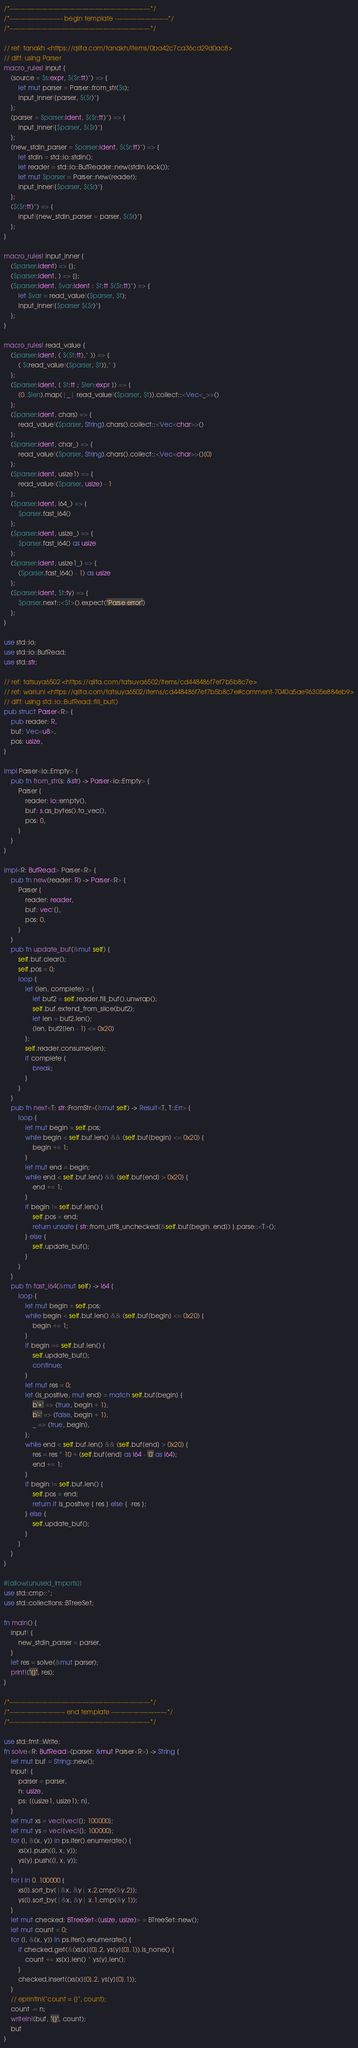Convert code to text. <code><loc_0><loc_0><loc_500><loc_500><_Rust_>/*------------------------------------------------------------------*/
/*------------------------- begin template -------------------------*/
/*------------------------------------------------------------------*/

// ref: tanakh <https://qiita.com/tanakh/items/0ba42c7ca36cd29d0ac8>
// diff: using Parser
macro_rules! input {
    (source = $s:expr, $($r:tt)*) => {
        let mut parser = Parser::from_str($s);
        input_inner!{parser, $($r)*}
    };
    (parser = $parser:ident, $($r:tt)*) => {
        input_inner!{$parser, $($r)*}
    };
    (new_stdin_parser = $parser:ident, $($r:tt)*) => {
        let stdin = std::io::stdin();
        let reader = std::io::BufReader::new(stdin.lock());
        let mut $parser = Parser::new(reader);
        input_inner!{$parser, $($r)*}
    };
    ($($r:tt)*) => {
        input!{new_stdin_parser = parser, $($r)*}
    };
}

macro_rules! input_inner {
    ($parser:ident) => {};
    ($parser:ident, ) => {};
    ($parser:ident, $var:ident : $t:tt $($r:tt)*) => {
        let $var = read_value!($parser, $t);
        input_inner!{$parser $($r)*}
    };
}

macro_rules! read_value {
    ($parser:ident, ( $($t:tt),* )) => {
        ( $(read_value!($parser, $t)),* )
    };
    ($parser:ident, [ $t:tt ; $len:expr ]) => {
        (0..$len).map(|_| read_value!($parser, $t)).collect::<Vec<_>>()
    };
    ($parser:ident, chars) => {
        read_value!($parser, String).chars().collect::<Vec<char>>()
    };
    ($parser:ident, char_) => {
        read_value!($parser, String).chars().collect::<Vec<char>>()[0]
    };
    ($parser:ident, usize1) => {
        read_value!($parser, usize) - 1
    };
    ($parser:ident, i64_) => {
        $parser.fast_i64()
    };
    ($parser:ident, usize_) => {
        $parser.fast_i64() as usize
    };
    ($parser:ident, usize1_) => {
        ($parser.fast_i64() - 1) as usize
    };
    ($parser:ident, $t:ty) => {
        $parser.next::<$t>().expect("Parse error")
    };
}

use std::io;
use std::io::BufRead;
use std::str;

// ref: tatsuya6502 <https://qiita.com/tatsuya6502/items/cd448486f7ef7b5b8c7e>
// ref: wariuni <https://qiita.com/tatsuya6502/items/cd448486f7ef7b5b8c7e#comment-7040a5ae96305e884eb9>
// diff: using std::io::BufRead::fill_buf()
pub struct Parser<R> {
    pub reader: R,
    buf: Vec<u8>,
    pos: usize,
}

impl Parser<io::Empty> {
    pub fn from_str(s: &str) -> Parser<io::Empty> {
        Parser {
            reader: io::empty(),
            buf: s.as_bytes().to_vec(),
            pos: 0,
        }
    }
}

impl<R: BufRead> Parser<R> {
    pub fn new(reader: R) -> Parser<R> {
        Parser {
            reader: reader,
            buf: vec![],
            pos: 0,
        }
    }
    pub fn update_buf(&mut self) {
        self.buf.clear();
        self.pos = 0;
        loop {
            let (len, complete) = {
                let buf2 = self.reader.fill_buf().unwrap();
                self.buf.extend_from_slice(buf2);
                let len = buf2.len();
                (len, buf2[len - 1] <= 0x20)
            };
            self.reader.consume(len);
            if complete {
                break;
            }
        }
    }
    pub fn next<T: str::FromStr>(&mut self) -> Result<T, T::Err> {
        loop {
            let mut begin = self.pos;
            while begin < self.buf.len() && (self.buf[begin] <= 0x20) {
                begin += 1;
            }
            let mut end = begin;
            while end < self.buf.len() && (self.buf[end] > 0x20) {
                end += 1;
            }
            if begin != self.buf.len() {
                self.pos = end;
                return unsafe { str::from_utf8_unchecked(&self.buf[begin..end]) }.parse::<T>();
            } else {
                self.update_buf();
            }
        }
    }
    pub fn fast_i64(&mut self) -> i64 {
        loop {
            let mut begin = self.pos;
            while begin < self.buf.len() && (self.buf[begin] <= 0x20) {
                begin += 1;
            }
            if begin == self.buf.len() {
                self.update_buf();
                continue;
            }
            let mut res = 0;
            let (is_positive, mut end) = match self.buf[begin] {
                b'+' => (true, begin + 1),
                b'-' => (false, begin + 1),
                _ => (true, begin),
            };
            while end < self.buf.len() && (self.buf[end] > 0x20) {
                res = res * 10 + (self.buf[end] as i64 - '0' as i64);
                end += 1;
            }
            if begin != self.buf.len() {
                self.pos = end;
                return if is_positive { res } else { -res };
            } else {
                self.update_buf();
            }
        }
    }
}

#[allow(unused_imports)]
use std::cmp::*;
use std::collections::BTreeSet;

fn main() {
    input! {
        new_stdin_parser = parser,
    }
    let res = solve(&mut parser);
    print!("{}", res);
}

/*------------------------------------------------------------------*/
/*-------------------------- end template --------------------------*/
/*------------------------------------------------------------------*/

use std::fmt::Write;
fn solve<R: BufRead>(parser: &mut Parser<R>) -> String {
    let mut buf = String::new();
    input! {
        parser = parser,
        n: usize,
        ps: [(usize1, usize1); n],
    }
    let mut xs = vec![vec![]; 100000];
    let mut ys = vec![vec![]; 100000];
    for (i, &(x, y)) in ps.iter().enumerate() {
        xs[x].push((i, x, y));
        ys[y].push((i, x, y));
    }
    for i in 0..100000 {
        xs[i].sort_by(|&x, &y| x.2.cmp(&y.2));
        ys[i].sort_by(|&x, &y| x.1.cmp(&y.1));
    }
    let mut checked: BTreeSet<(usize, usize)> = BTreeSet::new();
    let mut count = 0;
    for (i, &(x, y)) in ps.iter().enumerate() {
        if checked.get(&(xs[x][0].2, ys[y][0].1)).is_none() {
            count += xs[x].len() * ys[y].len();
        }
        checked.insert((xs[x][0].2, ys[y][0].1));
    }
    // eprintln!("count = {}", count);
    count -= n;
    writeln!(buf, "{}", count);
    buf
}
</code> 